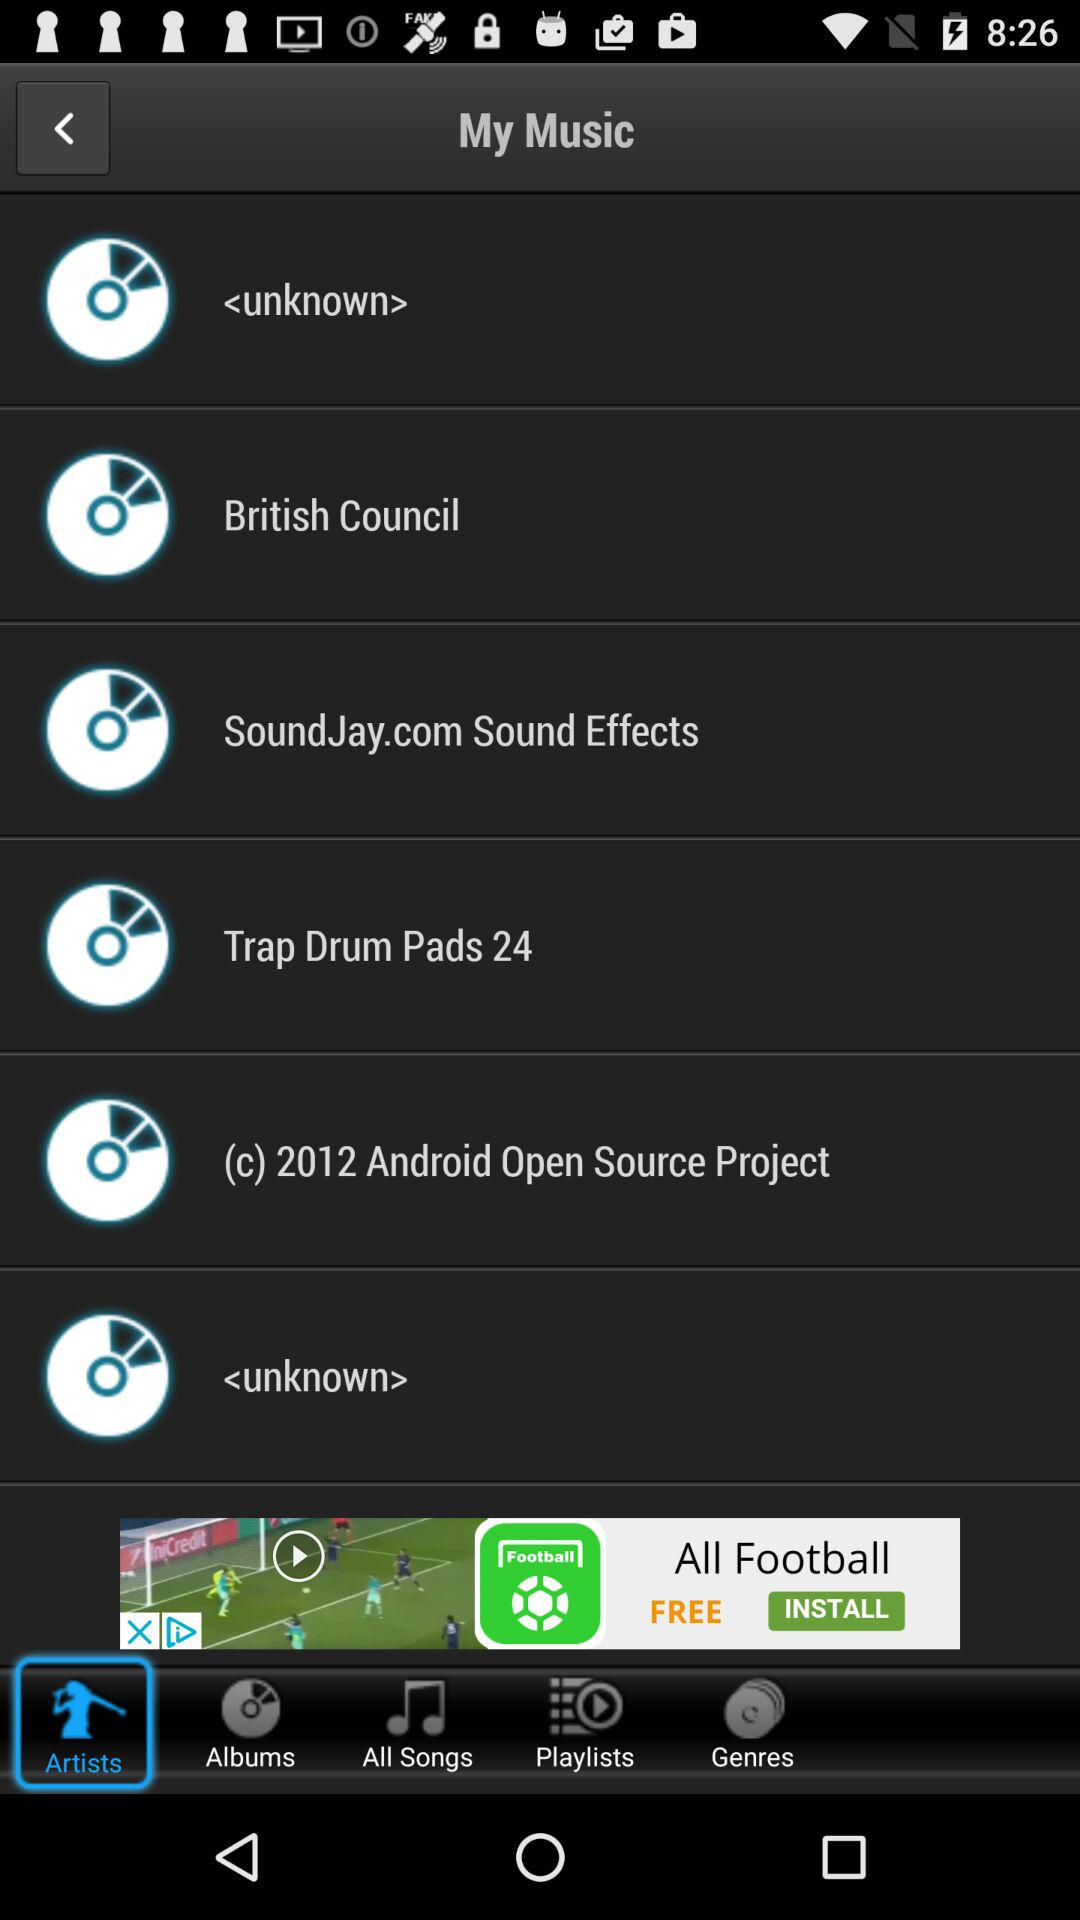Which tab is selected? The selected tab is "Artists". 